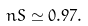<formula> <loc_0><loc_0><loc_500><loc_500>\ n S \simeq 0 . 9 7 .</formula> 